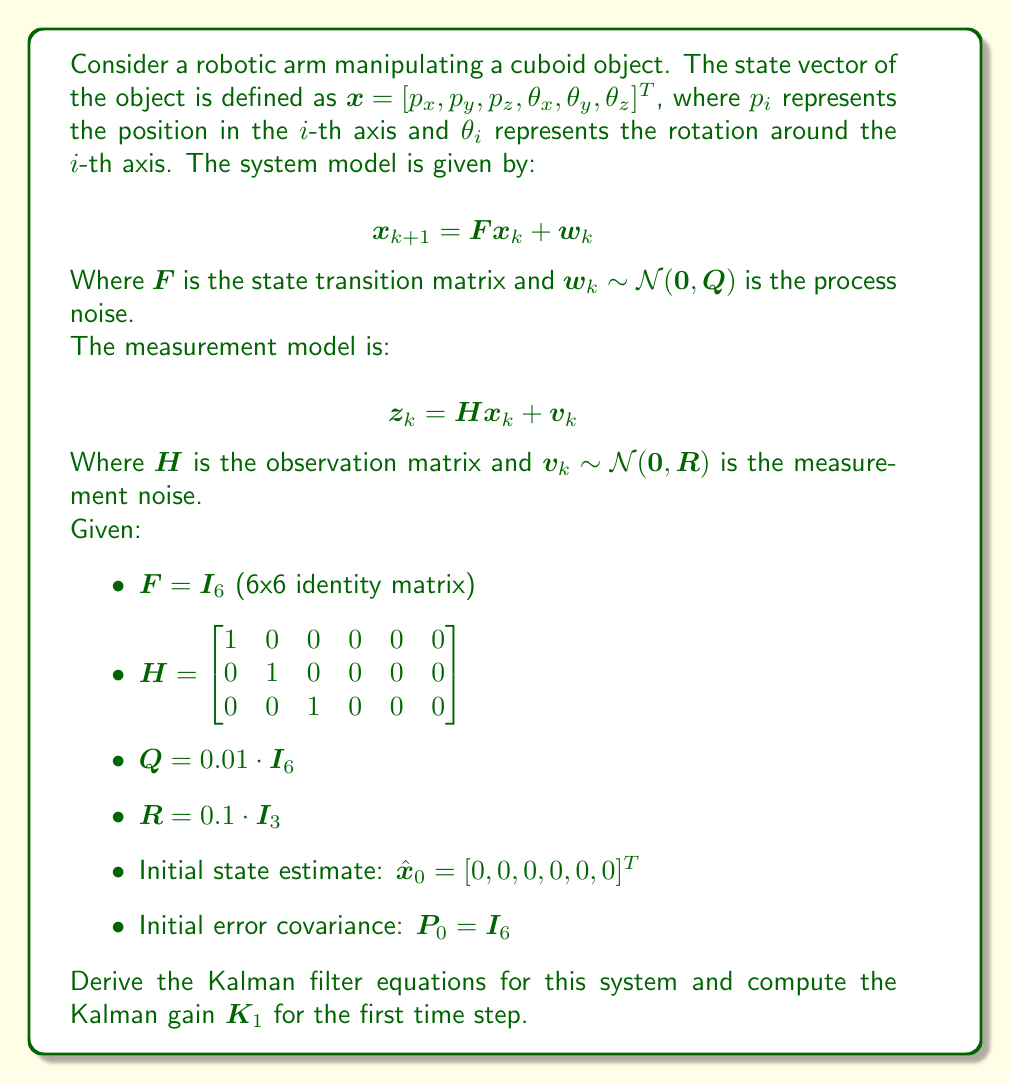Teach me how to tackle this problem. To derive the Kalman filter equations and compute the Kalman gain for the first time step, we'll follow these steps:

1. Kalman Filter Equations:
   The Kalman filter consists of two main steps: prediction and update.

   Prediction step:
   $$\hat{x}_{k|k-1} = F\hat{x}_{k-1|k-1}$$
   $$P_{k|k-1} = FP_{k-1|k-1}F^T + Q$$

   Update step:
   $$K_k = P_{k|k-1}H^T(HP_{k|k-1}H^T + R)^{-1}$$
   $$\hat{x}_{k|k} = \hat{x}_{k|k-1} + K_k(z_k - H\hat{x}_{k|k-1})$$
   $$P_{k|k} = (I - K_kH)P_{k|k-1}$$

2. Compute Kalman gain $K_1$:
   For the first time step, we start with the initial state estimate $\hat{x}_0$ and initial error covariance $P_0$.

   a. Prediction step:
      $$\hat{x}_{1|0} = F\hat{x}_0 = I_6 \cdot [0, 0, 0, 0, 0, 0]^T = [0, 0, 0, 0, 0, 0]^T$$
      $$P_{1|0} = FP_0F^T + Q = I_6 \cdot I_6 \cdot I_6 + 0.01 \cdot I_6 = 1.01 \cdot I_6$$

   b. Update step:
      Calculate Kalman gain $K_1$:
      $$K_1 = P_{1|0}H^T(HP_{1|0}H^T + R)^{-1}$$
      
      First, let's compute $HP_{1|0}H^T$:
      $$HP_{1|0}H^T = 1.01 \cdot \begin{bmatrix} 1 & 0 & 0 \\ 0 & 1 & 0 \\ 0 & 0 & 1 \end{bmatrix} = 1.01 \cdot I_3$$

      Now, we can calculate $(HP_{1|0}H^T + R)$:
      $$(HP_{1|0}H^T + R) = 1.01 \cdot I_3 + 0.1 \cdot I_3 = 1.11 \cdot I_3$$

      The inverse of this matrix is:
      $$(HP_{1|0}H^T + R)^{-1} = \frac{1}{1.11} \cdot I_3$$

      Finally, we can compute $K_1$:
      $$K_1 = 1.01 \cdot \begin{bmatrix} 1 & 0 & 0 \\ 0 & 1 & 0 \\ 0 & 0 & 1 \\ 0 & 0 & 0 \\ 0 & 0 & 0 \\ 0 & 0 & 0 \end{bmatrix} \cdot \frac{1}{1.11} \cdot I_3$$

      $$K_1 = \frac{1.01}{1.11} \cdot \begin{bmatrix} 1 & 0 & 0 \\ 0 & 1 & 0 \\ 0 & 0 & 1 \\ 0 & 0 & 0 \\ 0 & 0 & 0 \\ 0 & 0 & 0 \end{bmatrix} \approx 0.9099 \cdot \begin{bmatrix} 1 & 0 & 0 \\ 0 & 1 & 0 \\ 0 & 0 & 1 \\ 0 & 0 & 0 \\ 0 & 0 & 0 \\ 0 & 0 & 0 \end{bmatrix}$$
Answer: The Kalman gain $K_1$ for the first time step is:

$$K_1 \approx 0.9099 \cdot \begin{bmatrix} 1 & 0 & 0 \\ 0 & 1 & 0 \\ 0 & 0 & 1 \\ 0 & 0 & 0 \\ 0 & 0 & 0 \\ 0 & 0 & 0 \end{bmatrix}$$ 